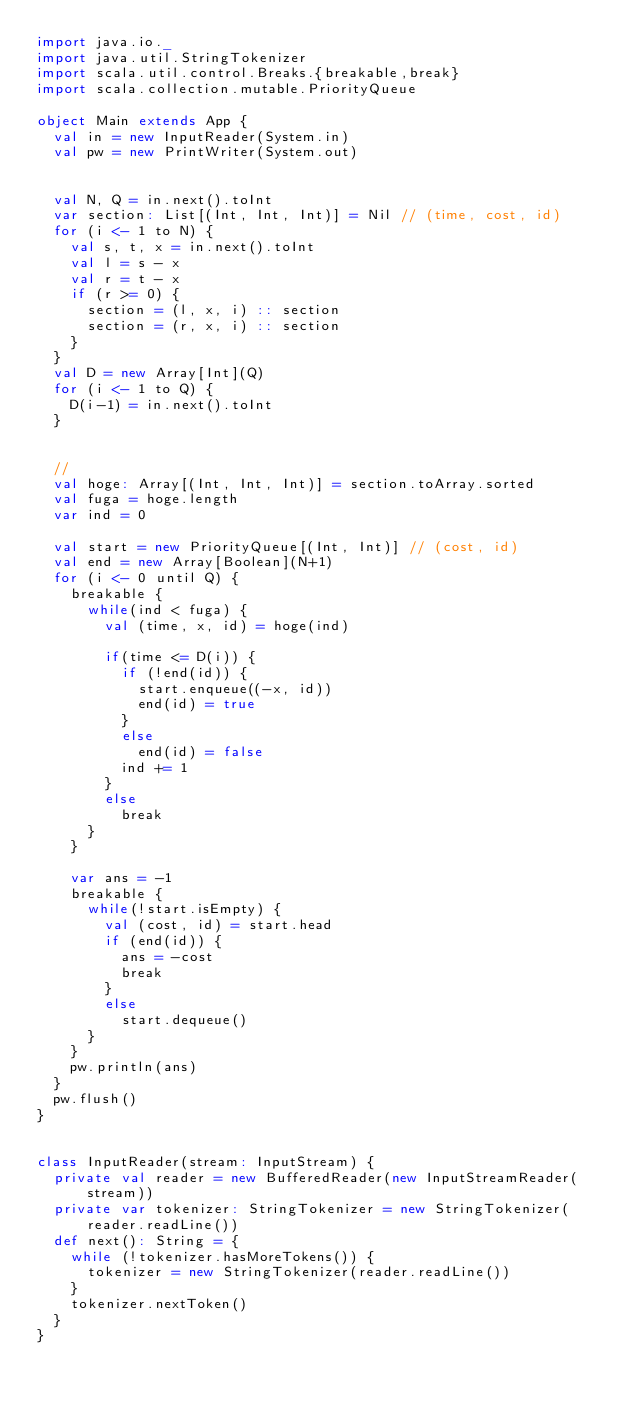<code> <loc_0><loc_0><loc_500><loc_500><_Scala_>import java.io._
import java.util.StringTokenizer
import scala.util.control.Breaks.{breakable,break}
import scala.collection.mutable.PriorityQueue

object Main extends App {
  val in = new InputReader(System.in)
  val pw = new PrintWriter(System.out)


  val N, Q = in.next().toInt
  var section: List[(Int, Int, Int)] = Nil // (time, cost, id)
  for (i <- 1 to N) {
    val s, t, x = in.next().toInt
    val l = s - x
    val r = t - x
    if (r >= 0) {
      section = (l, x, i) :: section
      section = (r, x, i) :: section
    }
  }
  val D = new Array[Int](Q)
  for (i <- 1 to Q) {
    D(i-1) = in.next().toInt
  }


  //
  val hoge: Array[(Int, Int, Int)] = section.toArray.sorted
  val fuga = hoge.length
  var ind = 0

  val start = new PriorityQueue[(Int, Int)] // (cost, id)
  val end = new Array[Boolean](N+1)
  for (i <- 0 until Q) {
    breakable {
      while(ind < fuga) {
        val (time, x, id) = hoge(ind)

        if(time <= D(i)) {
          if (!end(id)) {
            start.enqueue((-x, id))
            end(id) = true
          }
          else
            end(id) = false
          ind += 1
        }
        else
          break
      }
    }

    var ans = -1
    breakable {
      while(!start.isEmpty) {
        val (cost, id) = start.head
        if (end(id)) {
          ans = -cost
          break
        }
        else
          start.dequeue()
      }
    }
    pw.println(ans)
  }
  pw.flush()
}


class InputReader(stream: InputStream) {
  private val reader = new BufferedReader(new InputStreamReader(stream))
  private var tokenizer: StringTokenizer = new StringTokenizer(reader.readLine())
  def next(): String = {
    while (!tokenizer.hasMoreTokens()) {
      tokenizer = new StringTokenizer(reader.readLine())
    }
    tokenizer.nextToken()
  }
}
</code> 